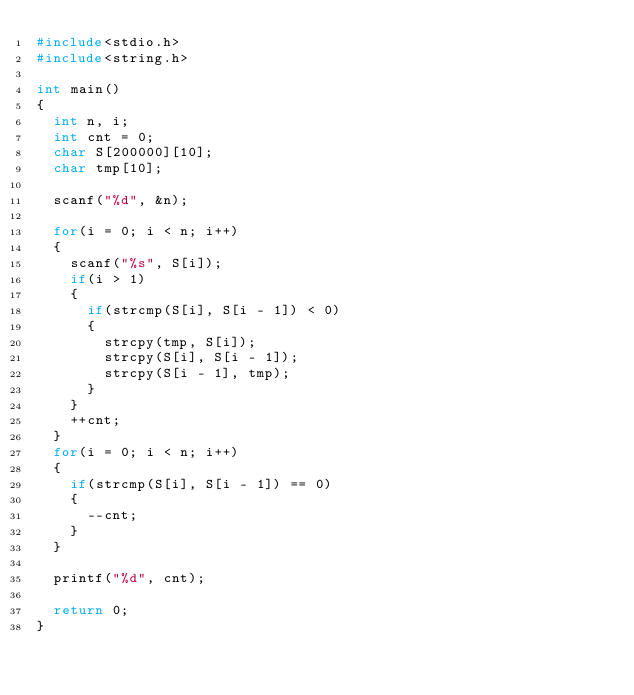Convert code to text. <code><loc_0><loc_0><loc_500><loc_500><_C_>#include<stdio.h>
#include<string.h>

int main()
{
  int n, i;
  int cnt = 0;
  char S[200000][10];
  char tmp[10];
  
  scanf("%d", &n);
  
  for(i = 0; i < n; i++)
  {
    scanf("%s", S[i]);
    if(i > 1)
    {
      if(strcmp(S[i], S[i - 1]) < 0)
      {
        strcpy(tmp, S[i]);
        strcpy(S[i], S[i - 1]);
        strcpy(S[i - 1], tmp);
      }
    }
    ++cnt;
  }
  for(i = 0; i < n; i++)
  {
    if(strcmp(S[i], S[i - 1]) == 0)
    {
      --cnt;
    }
  }
  
  printf("%d", cnt);

  return 0;
}</code> 